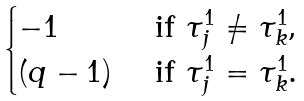Convert formula to latex. <formula><loc_0><loc_0><loc_500><loc_500>\begin{cases} - 1 & \text { if $\tau_{j}^{1} \neq \tau_{k}^{1}$,} \\ ( q - 1 ) & \text { if $\tau_{j}^{1} = \tau_{k}^{1}$.} \end{cases}</formula> 